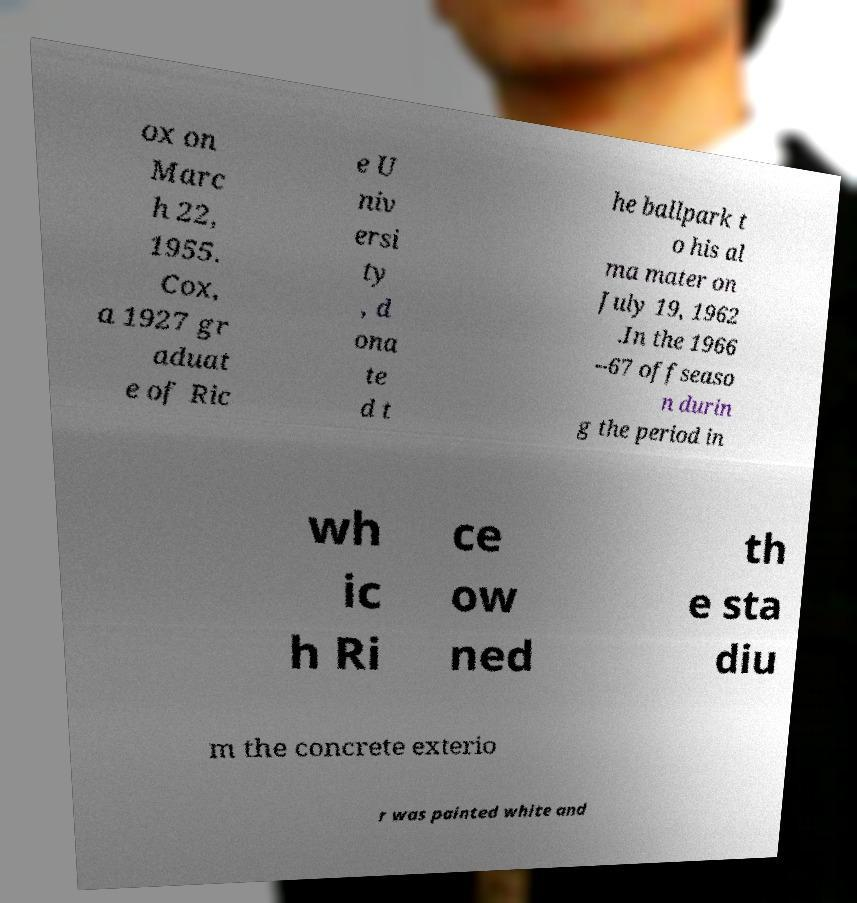For documentation purposes, I need the text within this image transcribed. Could you provide that? ox on Marc h 22, 1955. Cox, a 1927 gr aduat e of Ric e U niv ersi ty , d ona te d t he ballpark t o his al ma mater on July 19, 1962 .In the 1966 –67 offseaso n durin g the period in wh ic h Ri ce ow ned th e sta diu m the concrete exterio r was painted white and 